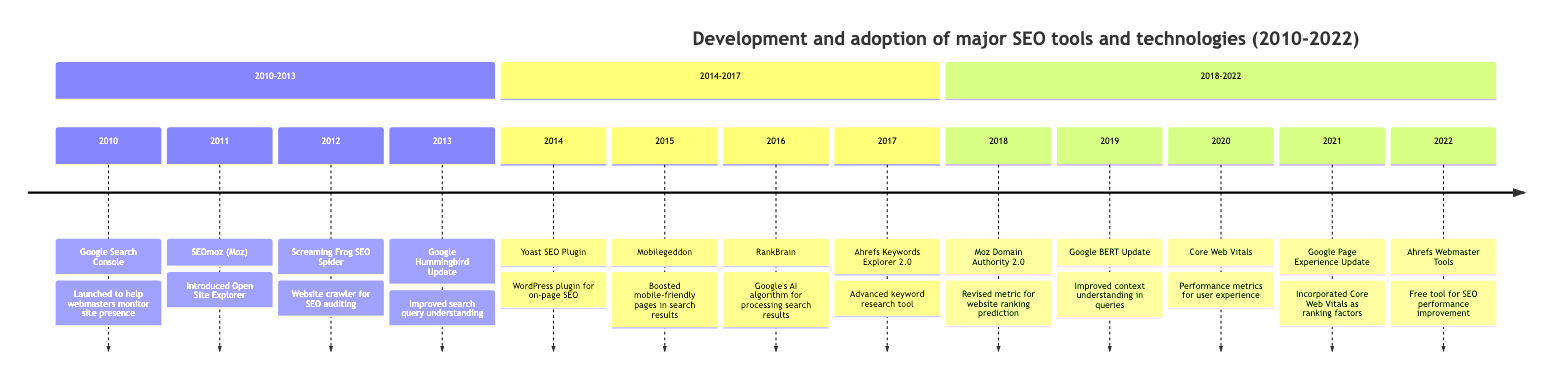What was the first SEO tool launched in the timeline? The first SEO tool in the timeline is Google Search Console, which was launched in 2010. This is evident from the first entry in the timeline section.
Answer: Google Search Console Which tool introduced a performance metrics set in 2020? The tool that introduced a performance metrics set in 2020 is Core Web Vitals. This can be identified by checking the entry for that year in the timeline.
Answer: Core Web Vitals How many tools were introduced between 2010 and 2013? There are four tools introduced between 2010 and 2013: Google Search Console, SEOmoz, Screaming Frog SEO Spider, and Google Hummingbird Update. Counting the entries in the relevant section confirms this.
Answer: 4 What significant update occurred in 2016? The significant update in 2016 is RankBrain. This is derived from the entry specifically labeled for that year.
Answer: RankBrain What was the main improvement of Yoast SEO Plugin in 2014? The main improvement of Yoast SEO Plugin in 2014 was the introduction of real-time content analysis and readability score features. This is detailed in the entry for that year in the timeline.
Answer: Real-time content analysis and readability score Which tool was launched in 2022 as a free SEO performance tool? The tool launched in 2022 as a free SEO performance tool is Ahrefs Webmaster Tools. By locating the last entry of the timeline, this can be confirmed.
Answer: Ahrefs Webmaster Tools What year did Google BERT Update come out? Google BERT Update was released in 2019, as indicated in the timeline under that specific year.
Answer: 2019 Which tool’s introduction coincided with the Mobile-Friendly Update in 2015? The introduction of Mobilegeddon coincided with Google’s Mobile-Friendly Update in 2015. This can be verified by viewing the entry details listed for that year.
Answer: Mobilegeddon 